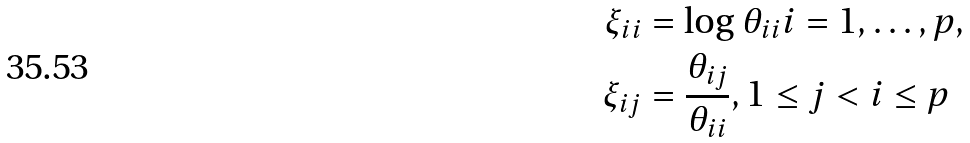Convert formula to latex. <formula><loc_0><loc_0><loc_500><loc_500>\xi _ { i i } & = \log \theta _ { i i } i = 1 , \dots , p , \\ \xi _ { i j } & = \frac { \theta _ { i j } } { \theta _ { i i } } , 1 \leq j < i \leq p</formula> 